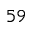<formula> <loc_0><loc_0><loc_500><loc_500>^ { 5 9 }</formula> 